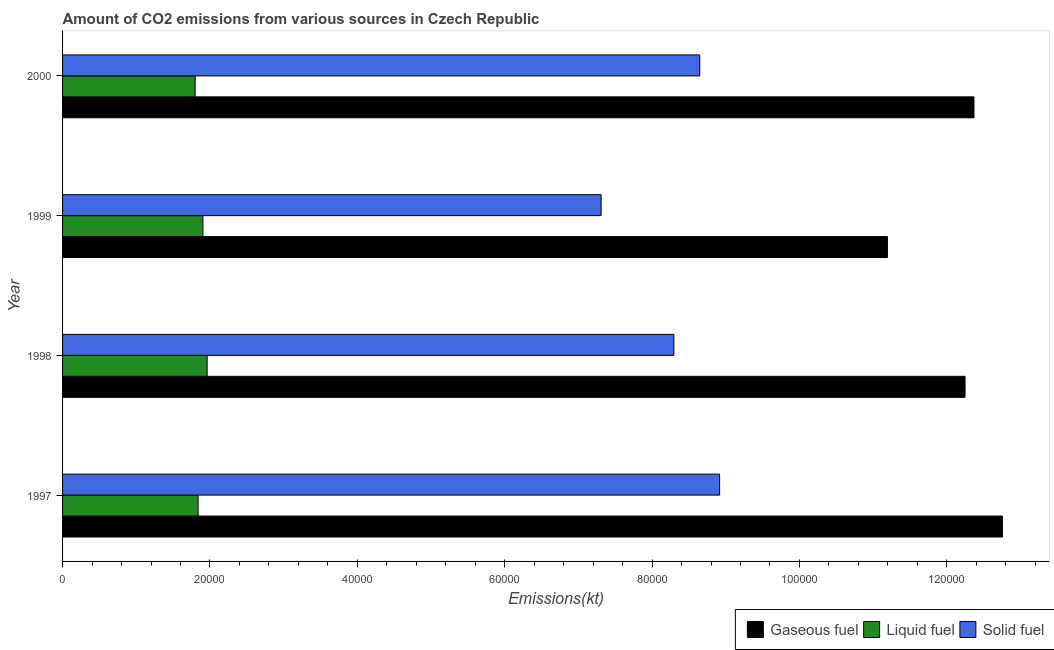How many different coloured bars are there?
Provide a succinct answer. 3. How many groups of bars are there?
Offer a very short reply. 4. Are the number of bars per tick equal to the number of legend labels?
Offer a terse response. Yes. How many bars are there on the 4th tick from the bottom?
Offer a terse response. 3. What is the label of the 3rd group of bars from the top?
Offer a terse response. 1998. What is the amount of co2 emissions from solid fuel in 2000?
Ensure brevity in your answer.  8.65e+04. Across all years, what is the maximum amount of co2 emissions from gaseous fuel?
Offer a terse response. 1.28e+05. Across all years, what is the minimum amount of co2 emissions from solid fuel?
Offer a very short reply. 7.31e+04. In which year was the amount of co2 emissions from gaseous fuel maximum?
Your answer should be very brief. 1997. What is the total amount of co2 emissions from solid fuel in the graph?
Give a very brief answer. 3.32e+05. What is the difference between the amount of co2 emissions from gaseous fuel in 1998 and that in 2000?
Provide a succinct answer. -1213.78. What is the difference between the amount of co2 emissions from gaseous fuel in 2000 and the amount of co2 emissions from solid fuel in 1998?
Make the answer very short. 4.07e+04. What is the average amount of co2 emissions from solid fuel per year?
Your response must be concise. 8.29e+04. In the year 1999, what is the difference between the amount of co2 emissions from liquid fuel and amount of co2 emissions from gaseous fuel?
Offer a very short reply. -9.29e+04. In how many years, is the amount of co2 emissions from solid fuel greater than 104000 kt?
Provide a short and direct response. 0. What is the ratio of the amount of co2 emissions from liquid fuel in 1998 to that in 2000?
Give a very brief answer. 1.09. Is the amount of co2 emissions from gaseous fuel in 1997 less than that in 1998?
Your answer should be compact. No. What is the difference between the highest and the second highest amount of co2 emissions from liquid fuel?
Offer a very short reply. 575.72. What is the difference between the highest and the lowest amount of co2 emissions from liquid fuel?
Give a very brief answer. 1624.48. In how many years, is the amount of co2 emissions from gaseous fuel greater than the average amount of co2 emissions from gaseous fuel taken over all years?
Offer a very short reply. 3. Is the sum of the amount of co2 emissions from gaseous fuel in 1997 and 2000 greater than the maximum amount of co2 emissions from liquid fuel across all years?
Keep it short and to the point. Yes. What does the 3rd bar from the top in 1998 represents?
Provide a short and direct response. Gaseous fuel. What does the 2nd bar from the bottom in 2000 represents?
Give a very brief answer. Liquid fuel. Is it the case that in every year, the sum of the amount of co2 emissions from gaseous fuel and amount of co2 emissions from liquid fuel is greater than the amount of co2 emissions from solid fuel?
Your answer should be compact. Yes. How many bars are there?
Give a very brief answer. 12. How many years are there in the graph?
Provide a short and direct response. 4. What is the difference between two consecutive major ticks on the X-axis?
Your answer should be compact. 2.00e+04. Does the graph contain any zero values?
Give a very brief answer. No. How many legend labels are there?
Make the answer very short. 3. How are the legend labels stacked?
Offer a terse response. Horizontal. What is the title of the graph?
Your answer should be compact. Amount of CO2 emissions from various sources in Czech Republic. Does "Hydroelectric sources" appear as one of the legend labels in the graph?
Your answer should be very brief. No. What is the label or title of the X-axis?
Offer a very short reply. Emissions(kt). What is the Emissions(kt) in Gaseous fuel in 1997?
Make the answer very short. 1.28e+05. What is the Emissions(kt) of Liquid fuel in 1997?
Give a very brief answer. 1.84e+04. What is the Emissions(kt) of Solid fuel in 1997?
Make the answer very short. 8.92e+04. What is the Emissions(kt) of Gaseous fuel in 1998?
Your response must be concise. 1.22e+05. What is the Emissions(kt) of Liquid fuel in 1998?
Provide a succinct answer. 1.96e+04. What is the Emissions(kt) of Solid fuel in 1998?
Your answer should be very brief. 8.30e+04. What is the Emissions(kt) in Gaseous fuel in 1999?
Provide a succinct answer. 1.12e+05. What is the Emissions(kt) in Liquid fuel in 1999?
Give a very brief answer. 1.90e+04. What is the Emissions(kt) of Solid fuel in 1999?
Offer a terse response. 7.31e+04. What is the Emissions(kt) of Gaseous fuel in 2000?
Your answer should be very brief. 1.24e+05. What is the Emissions(kt) in Liquid fuel in 2000?
Your answer should be very brief. 1.80e+04. What is the Emissions(kt) of Solid fuel in 2000?
Provide a short and direct response. 8.65e+04. Across all years, what is the maximum Emissions(kt) of Gaseous fuel?
Offer a terse response. 1.28e+05. Across all years, what is the maximum Emissions(kt) of Liquid fuel?
Your answer should be very brief. 1.96e+04. Across all years, what is the maximum Emissions(kt) in Solid fuel?
Make the answer very short. 8.92e+04. Across all years, what is the minimum Emissions(kt) in Gaseous fuel?
Give a very brief answer. 1.12e+05. Across all years, what is the minimum Emissions(kt) in Liquid fuel?
Your answer should be very brief. 1.80e+04. Across all years, what is the minimum Emissions(kt) in Solid fuel?
Provide a succinct answer. 7.31e+04. What is the total Emissions(kt) in Gaseous fuel in the graph?
Your answer should be very brief. 4.86e+05. What is the total Emissions(kt) in Liquid fuel in the graph?
Keep it short and to the point. 7.50e+04. What is the total Emissions(kt) in Solid fuel in the graph?
Keep it short and to the point. 3.32e+05. What is the difference between the Emissions(kt) of Gaseous fuel in 1997 and that in 1998?
Your response must be concise. 5082.46. What is the difference between the Emissions(kt) in Liquid fuel in 1997 and that in 1998?
Provide a succinct answer. -1224.78. What is the difference between the Emissions(kt) in Solid fuel in 1997 and that in 1998?
Your answer should be compact. 6208.23. What is the difference between the Emissions(kt) of Gaseous fuel in 1997 and that in 1999?
Ensure brevity in your answer.  1.56e+04. What is the difference between the Emissions(kt) in Liquid fuel in 1997 and that in 1999?
Offer a very short reply. -649.06. What is the difference between the Emissions(kt) in Solid fuel in 1997 and that in 1999?
Your answer should be compact. 1.61e+04. What is the difference between the Emissions(kt) in Gaseous fuel in 1997 and that in 2000?
Your answer should be very brief. 3868.68. What is the difference between the Emissions(kt) of Liquid fuel in 1997 and that in 2000?
Provide a short and direct response. 399.7. What is the difference between the Emissions(kt) of Solid fuel in 1997 and that in 2000?
Provide a succinct answer. 2691.58. What is the difference between the Emissions(kt) in Gaseous fuel in 1998 and that in 1999?
Offer a very short reply. 1.05e+04. What is the difference between the Emissions(kt) in Liquid fuel in 1998 and that in 1999?
Your answer should be very brief. 575.72. What is the difference between the Emissions(kt) in Solid fuel in 1998 and that in 1999?
Your answer should be very brief. 9871.56. What is the difference between the Emissions(kt) of Gaseous fuel in 1998 and that in 2000?
Give a very brief answer. -1213.78. What is the difference between the Emissions(kt) in Liquid fuel in 1998 and that in 2000?
Keep it short and to the point. 1624.48. What is the difference between the Emissions(kt) of Solid fuel in 1998 and that in 2000?
Provide a succinct answer. -3516.65. What is the difference between the Emissions(kt) of Gaseous fuel in 1999 and that in 2000?
Make the answer very short. -1.17e+04. What is the difference between the Emissions(kt) in Liquid fuel in 1999 and that in 2000?
Keep it short and to the point. 1048.76. What is the difference between the Emissions(kt) in Solid fuel in 1999 and that in 2000?
Ensure brevity in your answer.  -1.34e+04. What is the difference between the Emissions(kt) of Gaseous fuel in 1997 and the Emissions(kt) of Liquid fuel in 1998?
Provide a short and direct response. 1.08e+05. What is the difference between the Emissions(kt) of Gaseous fuel in 1997 and the Emissions(kt) of Solid fuel in 1998?
Your answer should be very brief. 4.46e+04. What is the difference between the Emissions(kt) of Liquid fuel in 1997 and the Emissions(kt) of Solid fuel in 1998?
Give a very brief answer. -6.46e+04. What is the difference between the Emissions(kt) of Gaseous fuel in 1997 and the Emissions(kt) of Liquid fuel in 1999?
Give a very brief answer. 1.09e+05. What is the difference between the Emissions(kt) of Gaseous fuel in 1997 and the Emissions(kt) of Solid fuel in 1999?
Your response must be concise. 5.45e+04. What is the difference between the Emissions(kt) in Liquid fuel in 1997 and the Emissions(kt) in Solid fuel in 1999?
Your response must be concise. -5.47e+04. What is the difference between the Emissions(kt) in Gaseous fuel in 1997 and the Emissions(kt) in Liquid fuel in 2000?
Provide a succinct answer. 1.10e+05. What is the difference between the Emissions(kt) of Gaseous fuel in 1997 and the Emissions(kt) of Solid fuel in 2000?
Make the answer very short. 4.11e+04. What is the difference between the Emissions(kt) in Liquid fuel in 1997 and the Emissions(kt) in Solid fuel in 2000?
Offer a terse response. -6.81e+04. What is the difference between the Emissions(kt) in Gaseous fuel in 1998 and the Emissions(kt) in Liquid fuel in 1999?
Offer a terse response. 1.03e+05. What is the difference between the Emissions(kt) of Gaseous fuel in 1998 and the Emissions(kt) of Solid fuel in 1999?
Offer a terse response. 4.94e+04. What is the difference between the Emissions(kt) of Liquid fuel in 1998 and the Emissions(kt) of Solid fuel in 1999?
Keep it short and to the point. -5.35e+04. What is the difference between the Emissions(kt) in Gaseous fuel in 1998 and the Emissions(kt) in Liquid fuel in 2000?
Give a very brief answer. 1.04e+05. What is the difference between the Emissions(kt) in Gaseous fuel in 1998 and the Emissions(kt) in Solid fuel in 2000?
Give a very brief answer. 3.60e+04. What is the difference between the Emissions(kt) in Liquid fuel in 1998 and the Emissions(kt) in Solid fuel in 2000?
Keep it short and to the point. -6.69e+04. What is the difference between the Emissions(kt) of Gaseous fuel in 1999 and the Emissions(kt) of Liquid fuel in 2000?
Provide a short and direct response. 9.39e+04. What is the difference between the Emissions(kt) of Gaseous fuel in 1999 and the Emissions(kt) of Solid fuel in 2000?
Ensure brevity in your answer.  2.55e+04. What is the difference between the Emissions(kt) of Liquid fuel in 1999 and the Emissions(kt) of Solid fuel in 2000?
Provide a short and direct response. -6.74e+04. What is the average Emissions(kt) in Gaseous fuel per year?
Offer a terse response. 1.21e+05. What is the average Emissions(kt) in Liquid fuel per year?
Give a very brief answer. 1.88e+04. What is the average Emissions(kt) of Solid fuel per year?
Provide a succinct answer. 8.29e+04. In the year 1997, what is the difference between the Emissions(kt) in Gaseous fuel and Emissions(kt) in Liquid fuel?
Make the answer very short. 1.09e+05. In the year 1997, what is the difference between the Emissions(kt) of Gaseous fuel and Emissions(kt) of Solid fuel?
Give a very brief answer. 3.84e+04. In the year 1997, what is the difference between the Emissions(kt) in Liquid fuel and Emissions(kt) in Solid fuel?
Offer a very short reply. -7.08e+04. In the year 1998, what is the difference between the Emissions(kt) in Gaseous fuel and Emissions(kt) in Liquid fuel?
Ensure brevity in your answer.  1.03e+05. In the year 1998, what is the difference between the Emissions(kt) of Gaseous fuel and Emissions(kt) of Solid fuel?
Give a very brief answer. 3.95e+04. In the year 1998, what is the difference between the Emissions(kt) in Liquid fuel and Emissions(kt) in Solid fuel?
Your answer should be very brief. -6.33e+04. In the year 1999, what is the difference between the Emissions(kt) of Gaseous fuel and Emissions(kt) of Liquid fuel?
Provide a succinct answer. 9.29e+04. In the year 1999, what is the difference between the Emissions(kt) of Gaseous fuel and Emissions(kt) of Solid fuel?
Provide a short and direct response. 3.89e+04. In the year 1999, what is the difference between the Emissions(kt) of Liquid fuel and Emissions(kt) of Solid fuel?
Offer a terse response. -5.40e+04. In the year 2000, what is the difference between the Emissions(kt) of Gaseous fuel and Emissions(kt) of Liquid fuel?
Make the answer very short. 1.06e+05. In the year 2000, what is the difference between the Emissions(kt) in Gaseous fuel and Emissions(kt) in Solid fuel?
Give a very brief answer. 3.72e+04. In the year 2000, what is the difference between the Emissions(kt) in Liquid fuel and Emissions(kt) in Solid fuel?
Provide a succinct answer. -6.85e+04. What is the ratio of the Emissions(kt) of Gaseous fuel in 1997 to that in 1998?
Offer a very short reply. 1.04. What is the ratio of the Emissions(kt) in Liquid fuel in 1997 to that in 1998?
Make the answer very short. 0.94. What is the ratio of the Emissions(kt) in Solid fuel in 1997 to that in 1998?
Keep it short and to the point. 1.07. What is the ratio of the Emissions(kt) in Gaseous fuel in 1997 to that in 1999?
Give a very brief answer. 1.14. What is the ratio of the Emissions(kt) of Liquid fuel in 1997 to that in 1999?
Your response must be concise. 0.97. What is the ratio of the Emissions(kt) in Solid fuel in 1997 to that in 1999?
Give a very brief answer. 1.22. What is the ratio of the Emissions(kt) of Gaseous fuel in 1997 to that in 2000?
Give a very brief answer. 1.03. What is the ratio of the Emissions(kt) of Liquid fuel in 1997 to that in 2000?
Keep it short and to the point. 1.02. What is the ratio of the Emissions(kt) in Solid fuel in 1997 to that in 2000?
Your response must be concise. 1.03. What is the ratio of the Emissions(kt) of Gaseous fuel in 1998 to that in 1999?
Keep it short and to the point. 1.09. What is the ratio of the Emissions(kt) in Liquid fuel in 1998 to that in 1999?
Make the answer very short. 1.03. What is the ratio of the Emissions(kt) in Solid fuel in 1998 to that in 1999?
Your response must be concise. 1.14. What is the ratio of the Emissions(kt) of Gaseous fuel in 1998 to that in 2000?
Keep it short and to the point. 0.99. What is the ratio of the Emissions(kt) in Liquid fuel in 1998 to that in 2000?
Your answer should be compact. 1.09. What is the ratio of the Emissions(kt) of Solid fuel in 1998 to that in 2000?
Provide a succinct answer. 0.96. What is the ratio of the Emissions(kt) of Gaseous fuel in 1999 to that in 2000?
Your response must be concise. 0.91. What is the ratio of the Emissions(kt) of Liquid fuel in 1999 to that in 2000?
Provide a short and direct response. 1.06. What is the ratio of the Emissions(kt) in Solid fuel in 1999 to that in 2000?
Provide a succinct answer. 0.85. What is the difference between the highest and the second highest Emissions(kt) of Gaseous fuel?
Give a very brief answer. 3868.68. What is the difference between the highest and the second highest Emissions(kt) of Liquid fuel?
Provide a short and direct response. 575.72. What is the difference between the highest and the second highest Emissions(kt) in Solid fuel?
Give a very brief answer. 2691.58. What is the difference between the highest and the lowest Emissions(kt) in Gaseous fuel?
Your answer should be compact. 1.56e+04. What is the difference between the highest and the lowest Emissions(kt) in Liquid fuel?
Offer a very short reply. 1624.48. What is the difference between the highest and the lowest Emissions(kt) of Solid fuel?
Offer a terse response. 1.61e+04. 